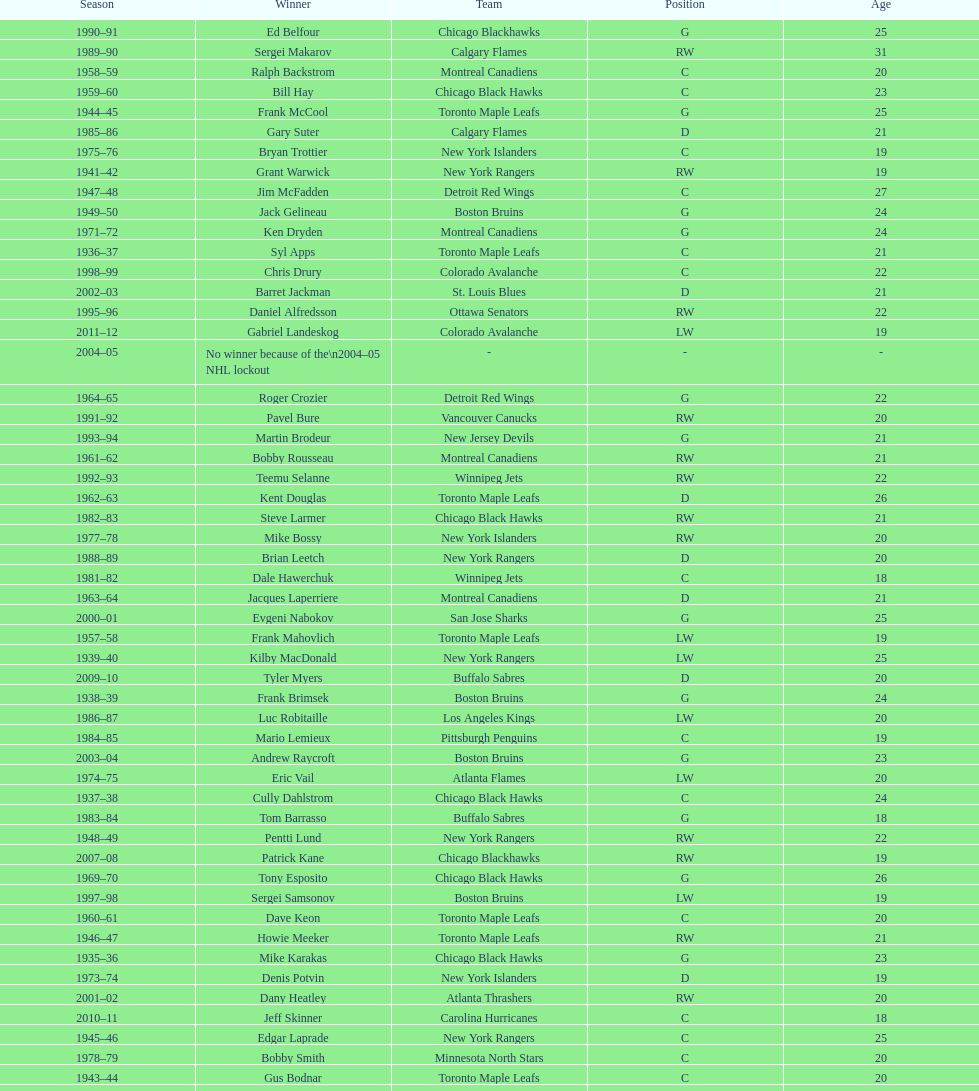How many times did the toronto maple leaves win? 9. 